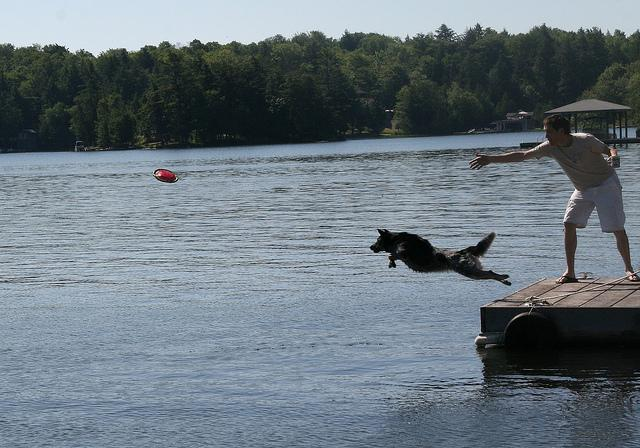What is the object called that the dog is jumping into the water after? frisbee 